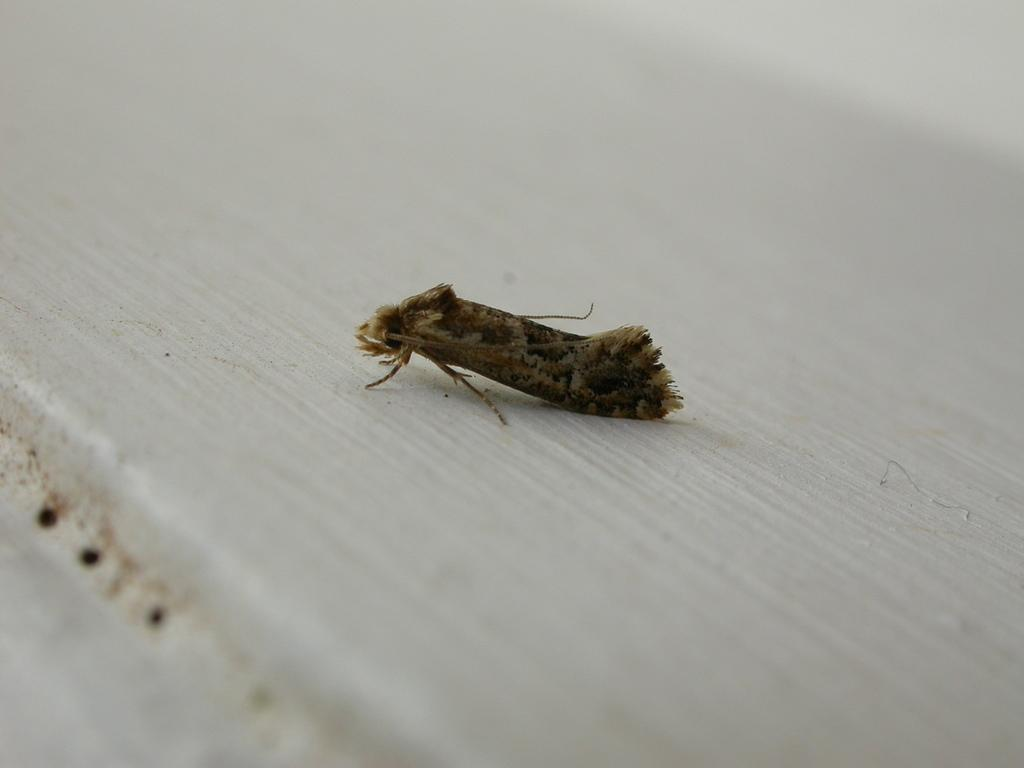What type of creature can be seen in the image? There is an insect in the image. Where is the insect located? The insect is on a surface. What type of zephyr can be seen in the image? There is no zephyr present in the image; it is an insect that can be seen. How many trains are visible in the image? There are no trains present in the image; it features an insect on a surface. 